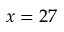Convert formula to latex. <formula><loc_0><loc_0><loc_500><loc_500>x = 2 7</formula> 